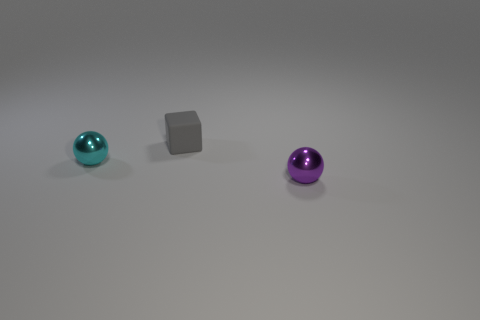Are there any other things that are the same material as the tiny block?
Ensure brevity in your answer.  No. What is the cyan ball made of?
Your answer should be very brief. Metal. How many purple metal things have the same size as the cyan shiny sphere?
Your answer should be very brief. 1. Is the number of tiny gray objects left of the gray matte thing the same as the number of cyan spheres left of the small purple metal thing?
Your answer should be very brief. No. Are the small purple sphere and the cyan sphere made of the same material?
Make the answer very short. Yes. There is a tiny purple metallic sphere that is right of the cyan shiny object; is there a small cyan ball that is behind it?
Your response must be concise. Yes. Is there another tiny cyan thing that has the same shape as the tiny cyan object?
Offer a very short reply. No. The small ball that is right of the object behind the cyan thing is made of what material?
Make the answer very short. Metal. Is the size of the ball that is in front of the cyan shiny object the same as the tiny cyan metal object?
Give a very brief answer. Yes. What shape is the matte thing that is to the right of the metal thing that is behind the thing right of the small gray object?
Offer a very short reply. Cube. 